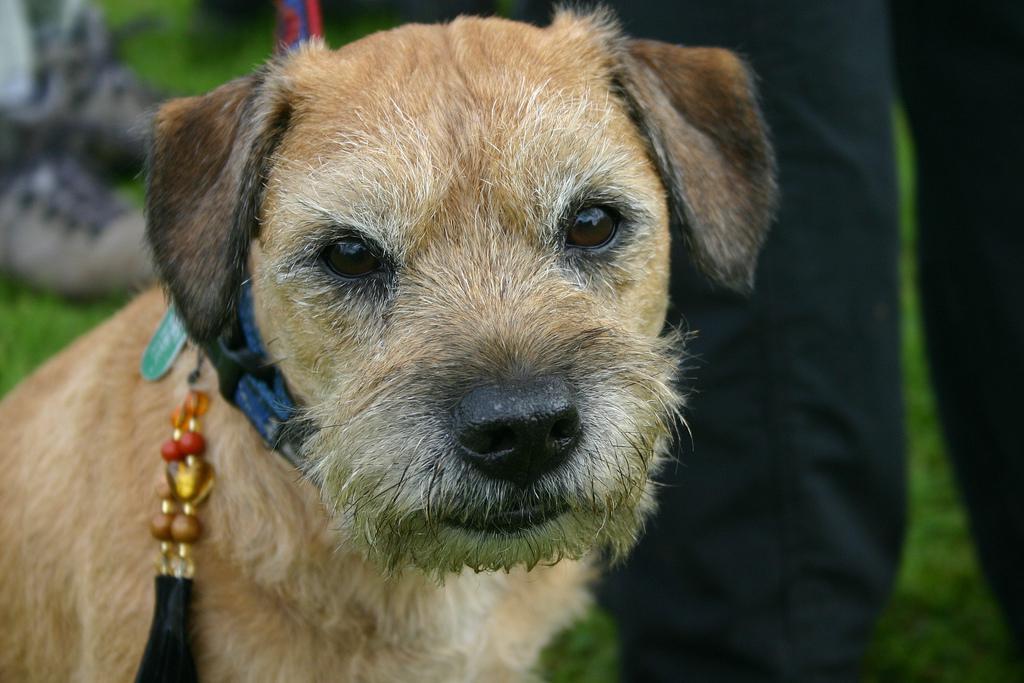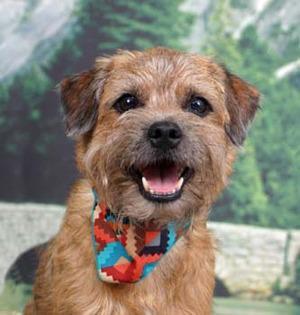The first image is the image on the left, the second image is the image on the right. Analyze the images presented: Is the assertion "An image shows one dog facing the camera directly, with mouth open." valid? Answer yes or no. Yes. The first image is the image on the left, the second image is the image on the right. For the images displayed, is the sentence "brightly colored collars are visible" factually correct? Answer yes or no. Yes. 